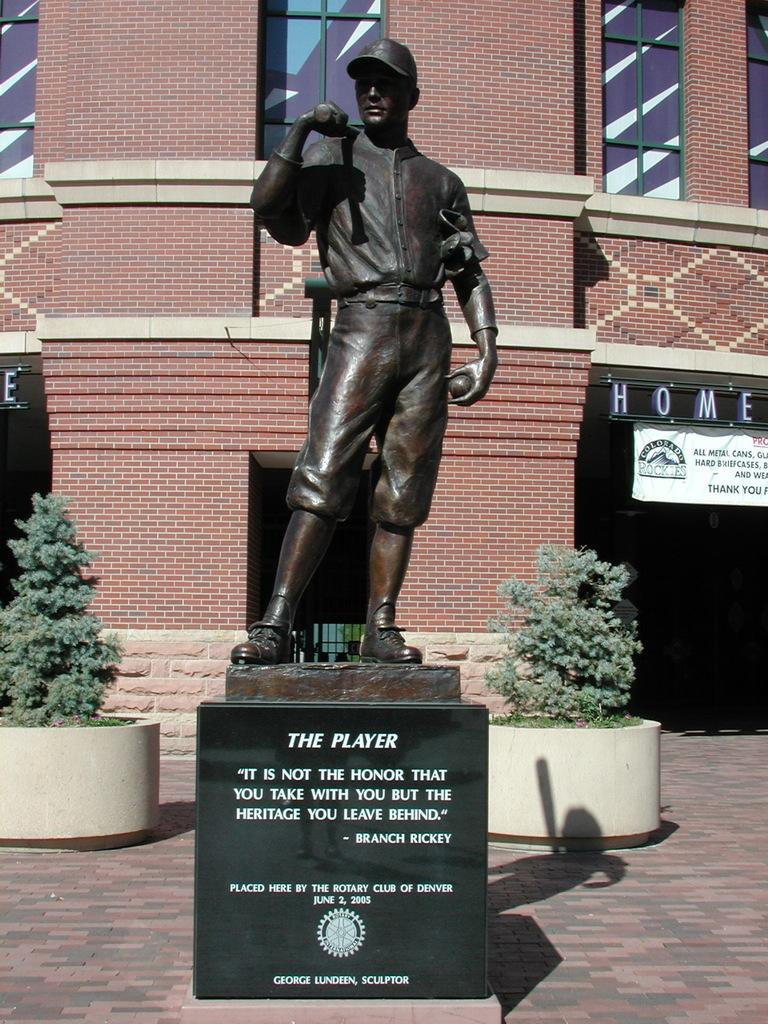What is the main subject of the image? There is a sculpture of a player in the image. What can be seen behind the sculpture? There are two plants behind the sculpture. What is visible in the background of the image? There is a building in the background of the image. How many trucks are parked near the sculpture in the image? There are no trucks visible in the image; it only features a sculpture, plants, and a building in the background. 